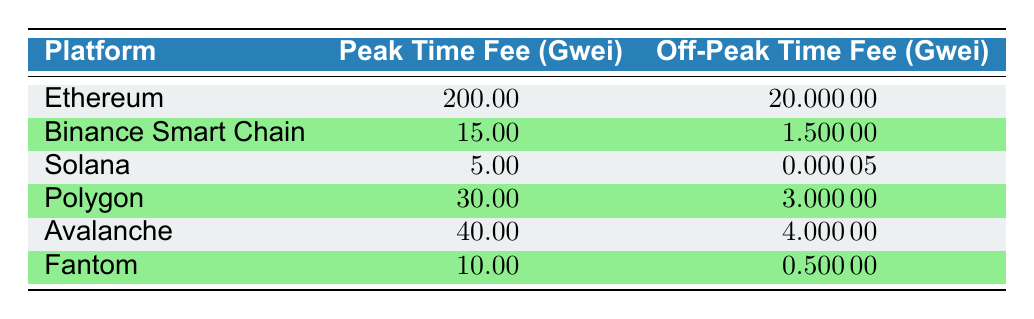What is the peak time fee for Ethereum? The table shows that the peak time fee for Ethereum is listed as 200.00 gwei, which is taken directly from the relevant row in the table under the "Peak Time Fee (Gwei)" column.
Answer: 200.00 gwei What is the off-peak time fee for Solana? Solana's off-peak time fee is shown in the table as 0.00005 gwei, which can be found in the corresponding row under the "Off-Peak Time Fee (Gwei)" column.
Answer: 0.00005 gwei Which platform has the highest peak time fee? By comparing the peak time fees listed in the table, Ethereum has the highest fee at 200.00 gwei, since no other platform has a fee that exceeds this amount.
Answer: Ethereum What is the difference between the peak time and off-peak time fee for Binance Smart Chain? The peak time fee for Binance Smart Chain is 15.00 gwei, and the off-peak fee is 1.50000 gwei. The difference is calculated by subtracting the off-peak fee from the peak fee: 15.00 - 1.50000 = 13.50 gwei.
Answer: 13.50 gwei Is the off-peak fee for Fantom greater than the off-peak fee for Avalanche? The off-peak fee for Fantom is 0.50000 gwei, while Avalanche's off-peak fee is 4.00000 gwei. Since 0.50000 is less than 4.00000, the statement is false.
Answer: No What is the average peak time fee across all platforms listed? To calculate the average, we first sum all the peak time fees: 200 + 15 + 5 + 30 + 40 + 10 = 300 gwei. There are 6 platforms, so the average is 300 / 6 = 50.00 gwei.
Answer: 50.00 gwei Which platform has the smallest difference between peak and off-peak time fees? By calculating the differences for each platform, we find that Solana has the smallest difference: 5.00 - 0.00005 = 4.99995 gwei. Comparing all platforms, Solana has the smallest difference.
Answer: Solana Do all platforms have a peak time fee lower than or equal to 50 gwei? The peak time fees for Ethereum (200.00 gwei) and Avalanche (40.00 gwei) are considered. Ethereum's fee exceeds 50 gwei, making the statement false.
Answer: No What is the range of peak time fees across the platforms? The peak time fees range from the lowest of 5.00 gwei (Solana) to the highest of 200.00 gwei (Ethereum). The range is calculated as highest - lowest, which is 200.00 - 5.00 = 195.00 gwei.
Answer: 195.00 gwei 